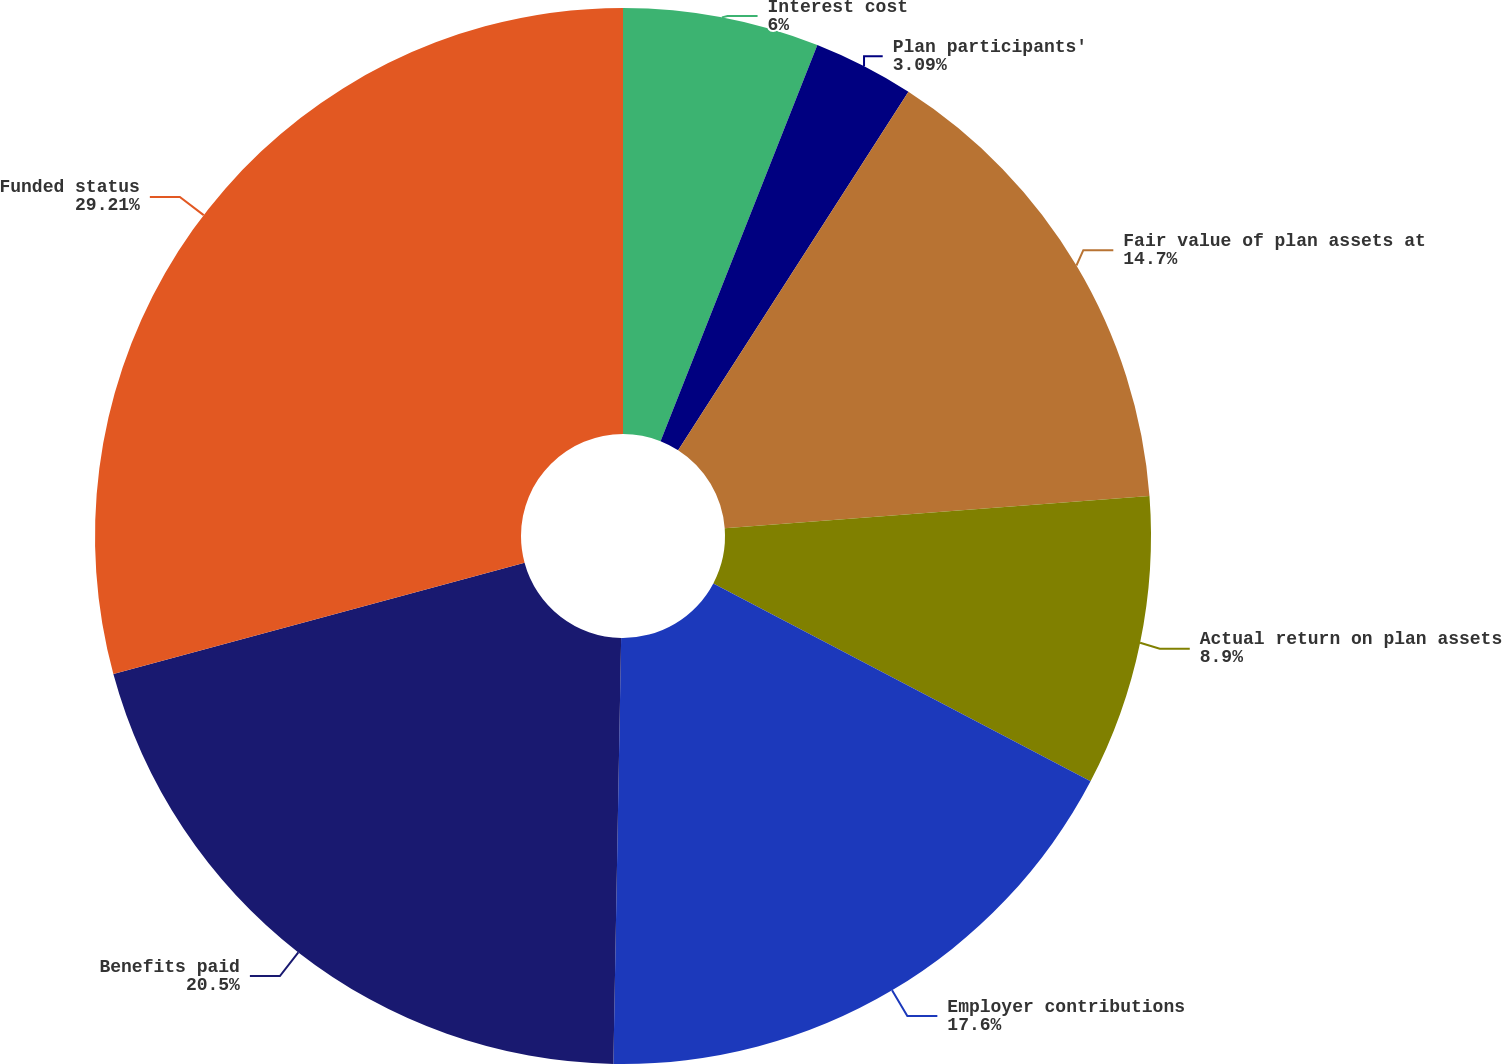Convert chart. <chart><loc_0><loc_0><loc_500><loc_500><pie_chart><fcel>Interest cost<fcel>Plan participants'<fcel>Fair value of plan assets at<fcel>Actual return on plan assets<fcel>Employer contributions<fcel>Benefits paid<fcel>Funded status<nl><fcel>6.0%<fcel>3.09%<fcel>14.7%<fcel>8.9%<fcel>17.6%<fcel>20.5%<fcel>29.21%<nl></chart> 